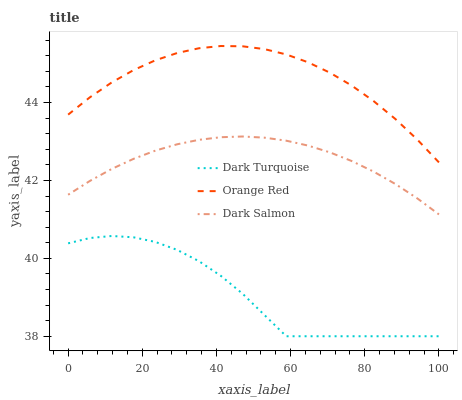Does Dark Turquoise have the minimum area under the curve?
Answer yes or no. Yes. Does Dark Salmon have the minimum area under the curve?
Answer yes or no. No. Does Dark Salmon have the maximum area under the curve?
Answer yes or no. No. Is Orange Red the smoothest?
Answer yes or no. No. Is Orange Red the roughest?
Answer yes or no. No. Does Dark Salmon have the lowest value?
Answer yes or no. No. Does Dark Salmon have the highest value?
Answer yes or no. No. Is Dark Turquoise less than Dark Salmon?
Answer yes or no. Yes. Is Dark Salmon greater than Dark Turquoise?
Answer yes or no. Yes. Does Dark Turquoise intersect Dark Salmon?
Answer yes or no. No. 